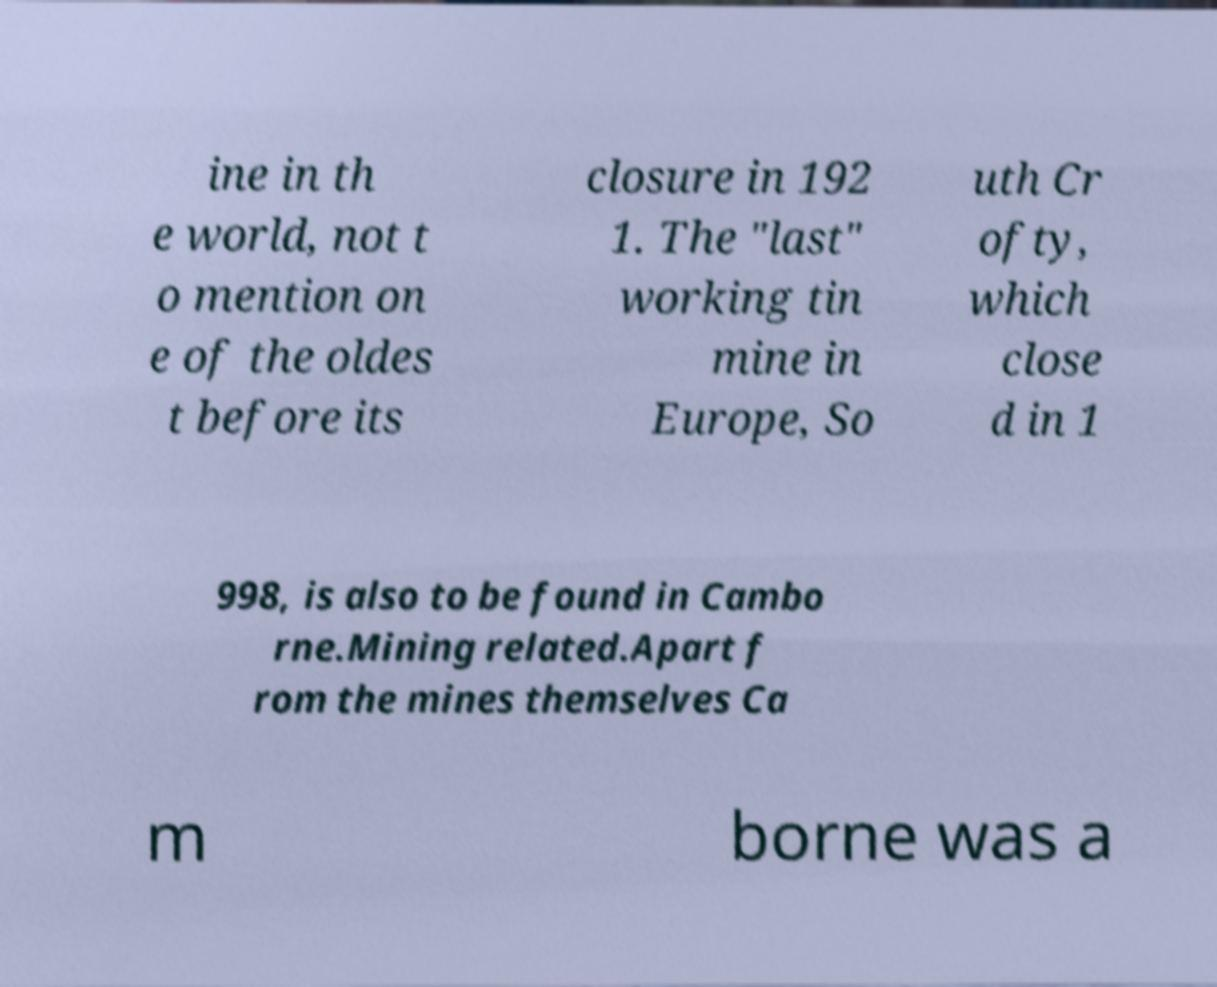I need the written content from this picture converted into text. Can you do that? ine in th e world, not t o mention on e of the oldes t before its closure in 192 1. The "last" working tin mine in Europe, So uth Cr ofty, which close d in 1 998, is also to be found in Cambo rne.Mining related.Apart f rom the mines themselves Ca m borne was a 